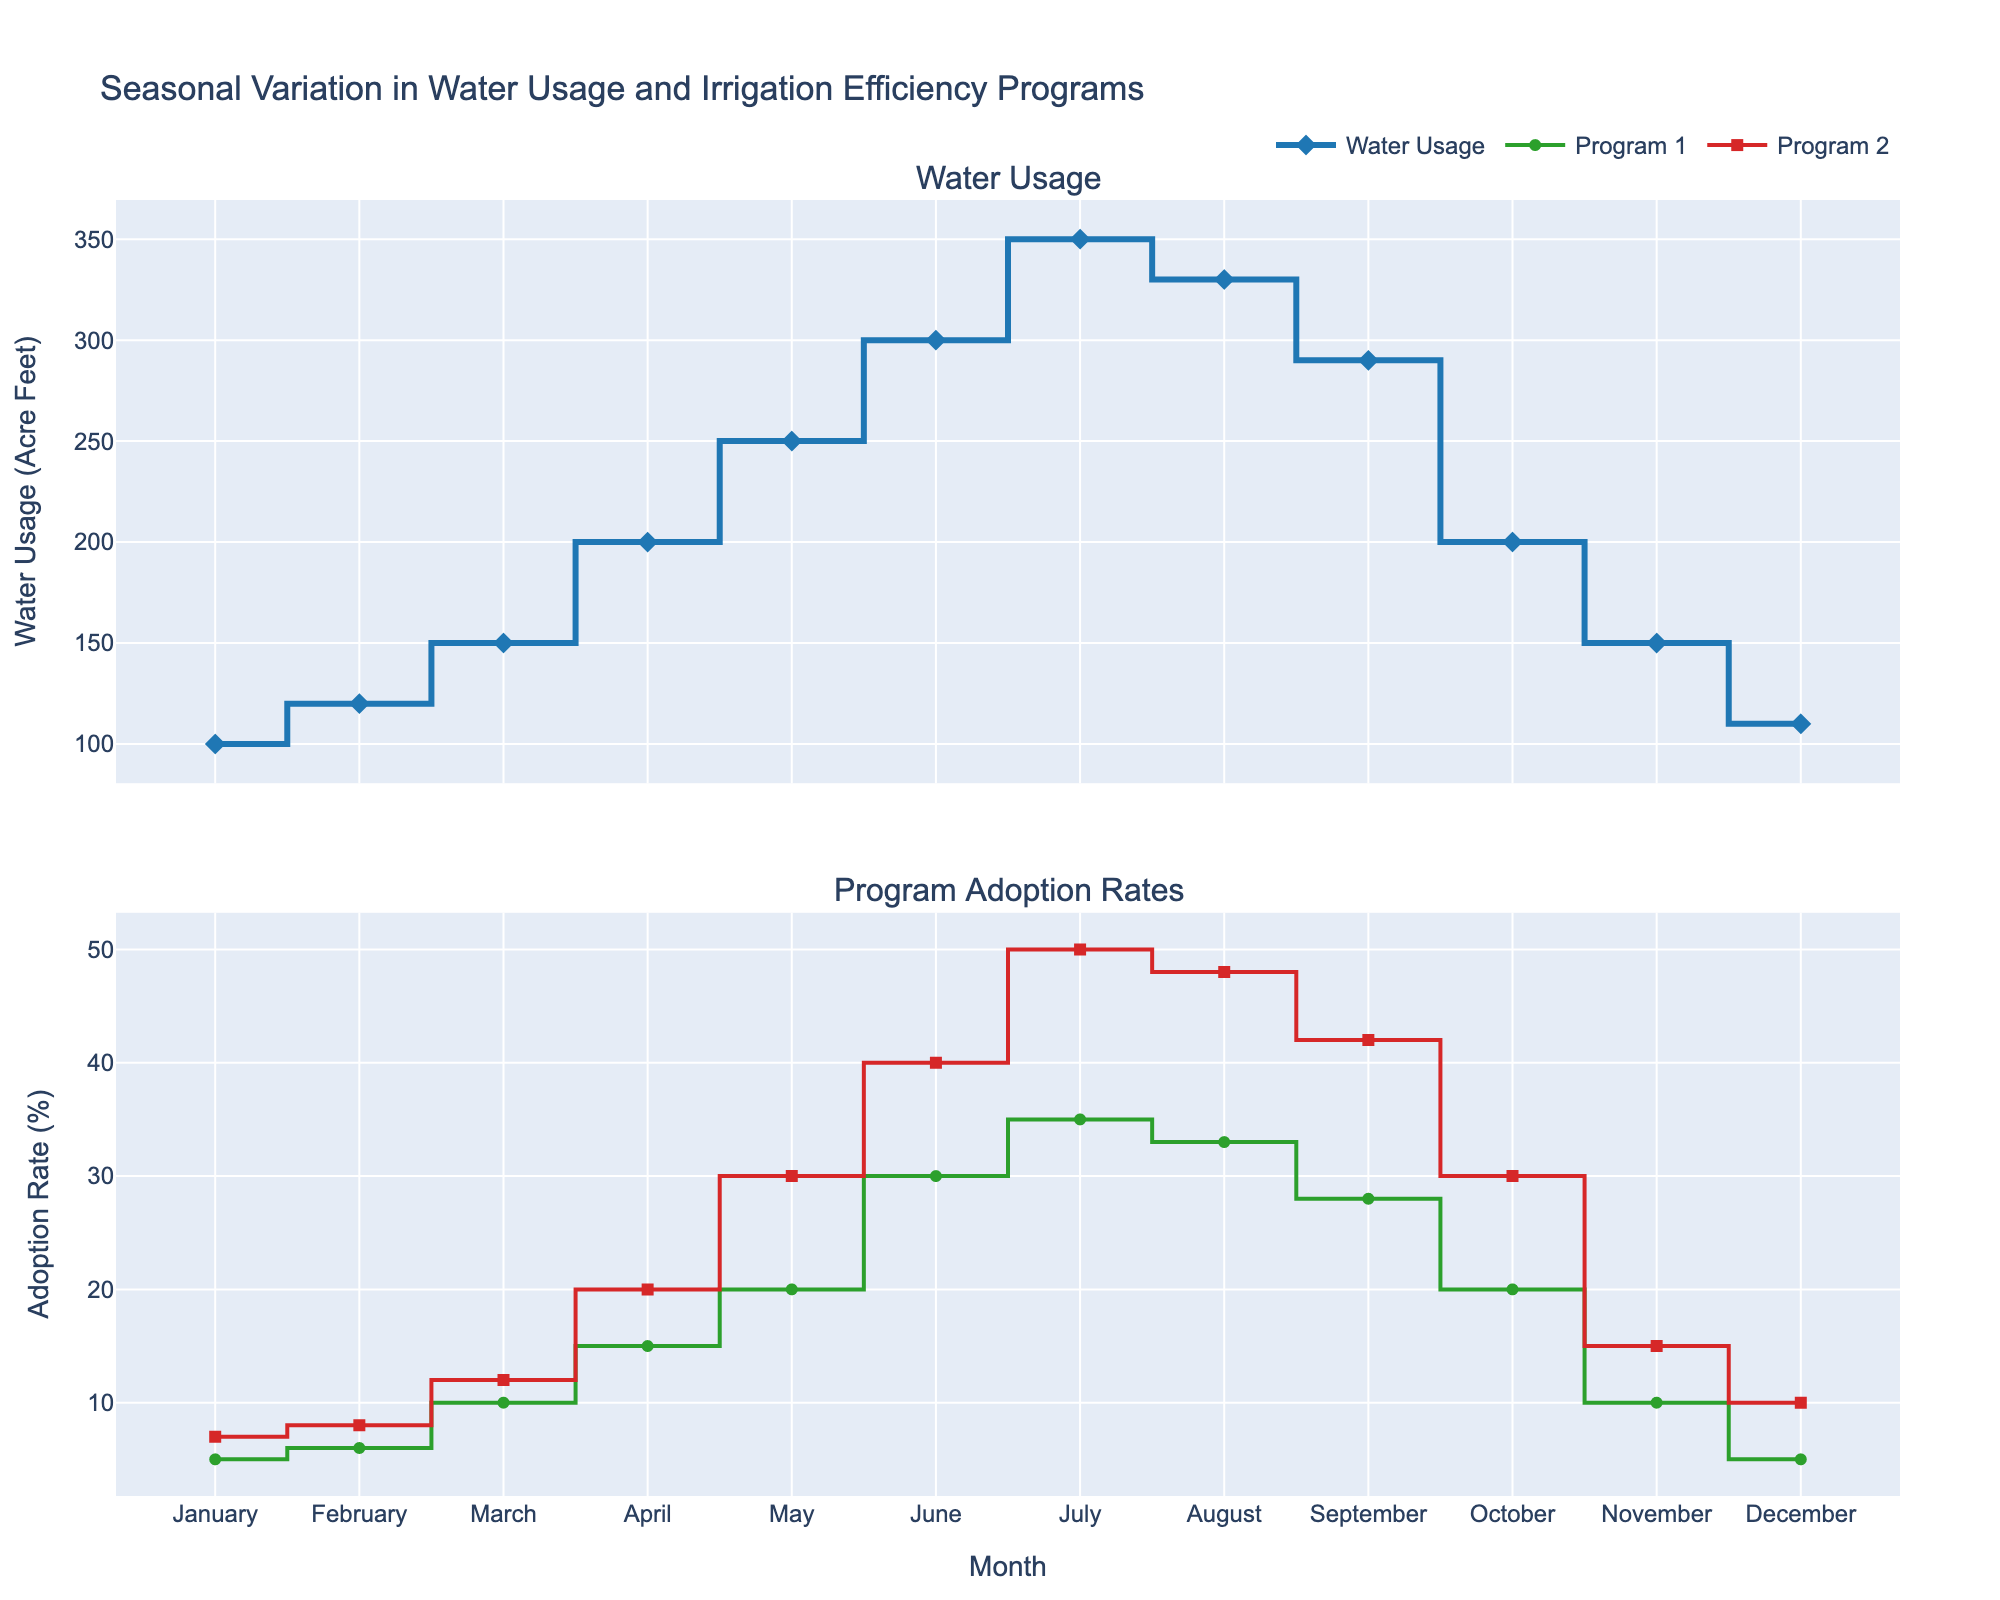What is the title of the figure? The title is located at the top of the figure and describes its main subject.
Answer: Seasonal Variation in Water Usage and Irrigation Efficiency Programs How many programs are tracked for adoption rates in the figure? Referring to the legend, there are two lines marked as Program 1 and Program 2.
Answer: Two During which month is the water usage the highest? Look at the figure's top subplot representing water usage and identify the peak point on the line.
Answer: July What is the average adoption rate of Program 1 across all months? To calculate the average, sum all monthly adoption rates of Program 1 and divide by 12: (5+6+10+15+20+30+35+33+28+20+10+5)/12
Answer: 17.5% Which month has the smallest difference between Program 1 and Program 2 adoption rates? Subtract Program 1 adoption rates from Program 2 for each month and find the smallest difference: In January (7-5=2). February (8-6=2), March (12-10=2), and so on.
Answer: January, February, and March (all 2%) Is there any month where water usage was less than the previous month? If so, which ones? Examine the stair-like plot for any downward steps. Identify months where the water usage line drops from the previous point.
Answer: August, September, October, November Which month has the highest combined adoption rate of both programs? Add the adoption rates of Program 1 and Program 2 for each month and determine the month with the highest total: July (35+50=85).
Answer: July How does the water usage in April compare to October? Compare the values of water usage in April and October by looking at their respective points: April (200) and October (200).
Answer: Equal Does the adoption rate of both programs increase, decrease, or stay the same from May to June? Refer to the two lines in the second subplot for both Program 1 (20 to 30) and Program 2 (30 to 40), both show an increase.
Answer: Increase 